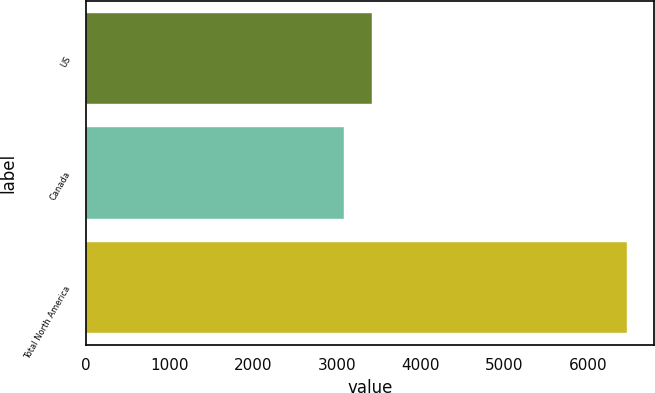Convert chart. <chart><loc_0><loc_0><loc_500><loc_500><bar_chart><fcel>US<fcel>Canada<fcel>Total North America<nl><fcel>3422.9<fcel>3085<fcel>6464<nl></chart> 